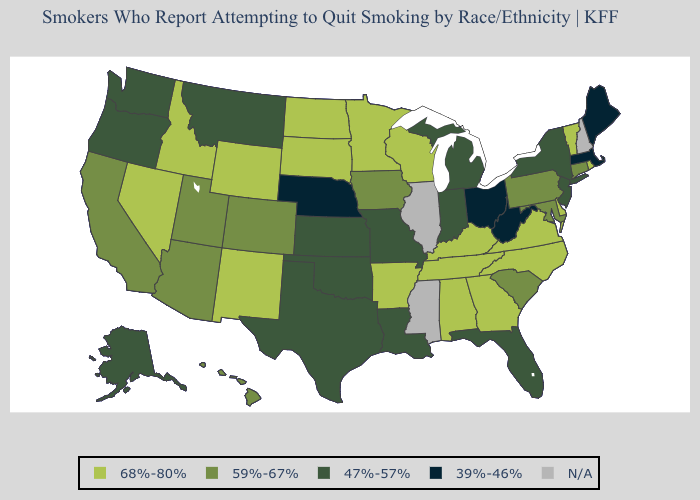Name the states that have a value in the range 68%-80%?
Short answer required. Alabama, Arkansas, Delaware, Georgia, Idaho, Kentucky, Minnesota, Nevada, New Mexico, North Carolina, North Dakota, Rhode Island, South Dakota, Tennessee, Vermont, Virginia, Wisconsin, Wyoming. What is the value of South Dakota?
Keep it brief. 68%-80%. What is the lowest value in the Northeast?
Quick response, please. 39%-46%. How many symbols are there in the legend?
Quick response, please. 5. Among the states that border Texas , does Arkansas have the lowest value?
Keep it brief. No. Which states have the highest value in the USA?
Concise answer only. Alabama, Arkansas, Delaware, Georgia, Idaho, Kentucky, Minnesota, Nevada, New Mexico, North Carolina, North Dakota, Rhode Island, South Dakota, Tennessee, Vermont, Virginia, Wisconsin, Wyoming. What is the value of Nevada?
Keep it brief. 68%-80%. What is the highest value in states that border North Dakota?
Short answer required. 68%-80%. What is the lowest value in states that border Kentucky?
Concise answer only. 39%-46%. What is the value of Alabama?
Answer briefly. 68%-80%. Name the states that have a value in the range 47%-57%?
Write a very short answer. Alaska, Florida, Indiana, Kansas, Louisiana, Michigan, Missouri, Montana, New Jersey, New York, Oklahoma, Oregon, Texas, Washington. What is the value of Alaska?
Quick response, please. 47%-57%. Is the legend a continuous bar?
Answer briefly. No. Does the first symbol in the legend represent the smallest category?
Answer briefly. No. 